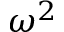<formula> <loc_0><loc_0><loc_500><loc_500>\omega ^ { 2 }</formula> 